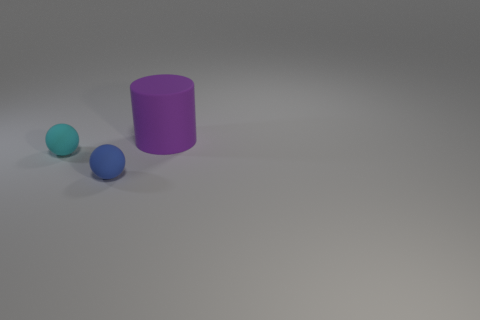What number of small spheres are the same material as the purple object?
Provide a short and direct response. 2. What color is the big rubber object?
Offer a terse response. Purple. What is the color of the other ball that is the same size as the blue ball?
Provide a succinct answer. Cyan. Are there any matte things that have the same color as the matte cylinder?
Keep it short and to the point. No. Do the tiny matte thing behind the tiny blue rubber ball and the tiny rubber object that is in front of the tiny cyan rubber object have the same shape?
Offer a terse response. Yes. How many other objects are there of the same size as the purple thing?
Make the answer very short. 0. Is the number of small cyan objects in front of the purple cylinder less than the number of matte things to the right of the cyan ball?
Ensure brevity in your answer.  Yes. The thing that is right of the small cyan object and behind the blue thing is what color?
Offer a terse response. Purple. Is the size of the purple cylinder the same as the matte object that is in front of the tiny cyan rubber thing?
Your answer should be compact. No. What is the shape of the small rubber thing to the left of the blue object?
Your answer should be very brief. Sphere. 